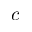Convert formula to latex. <formula><loc_0><loc_0><loc_500><loc_500>c</formula> 